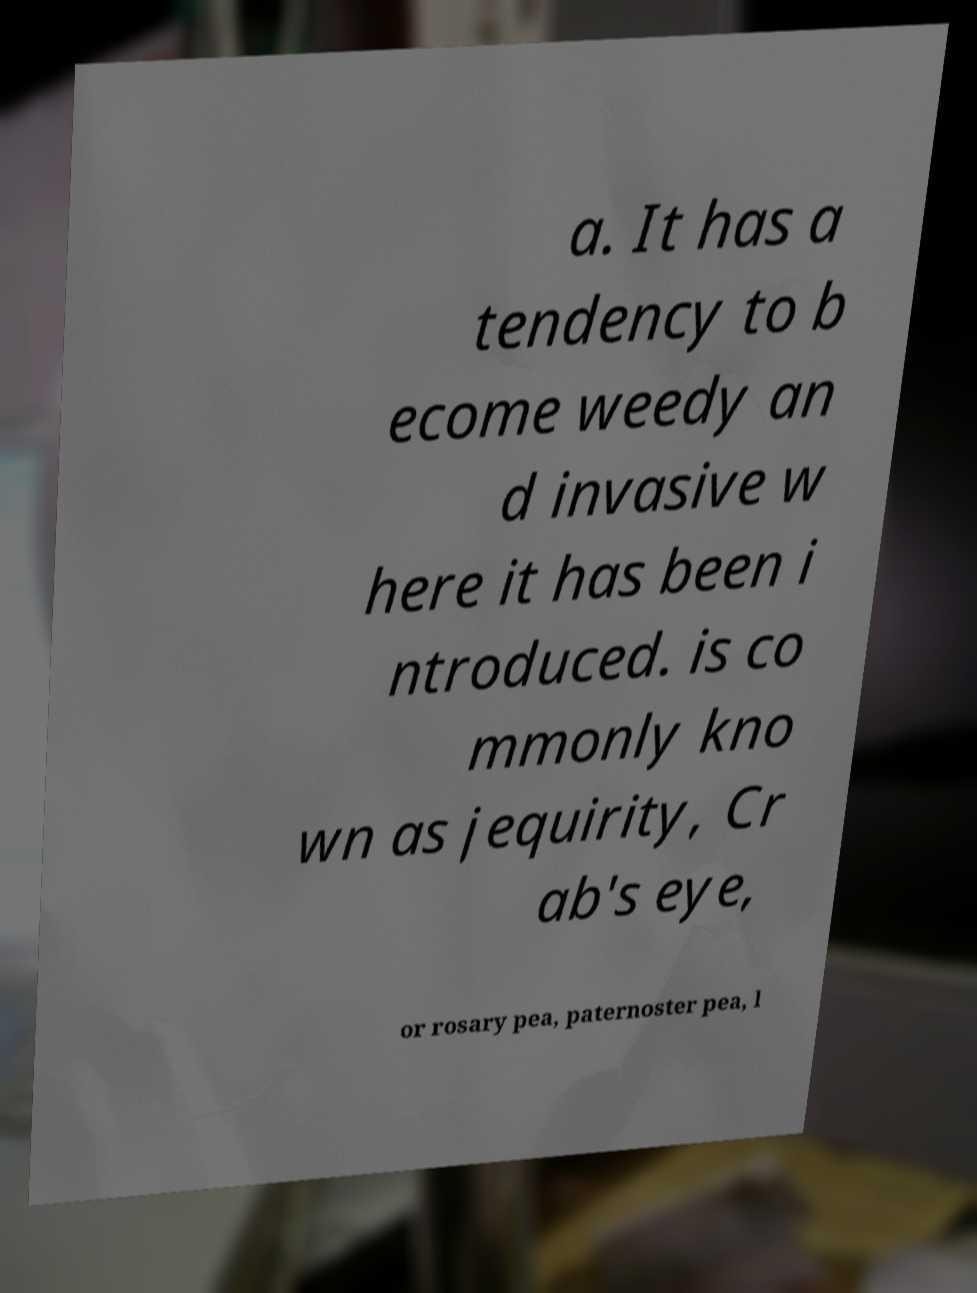Can you accurately transcribe the text from the provided image for me? a. It has a tendency to b ecome weedy an d invasive w here it has been i ntroduced. is co mmonly kno wn as jequirity, Cr ab's eye, or rosary pea, paternoster pea, l 